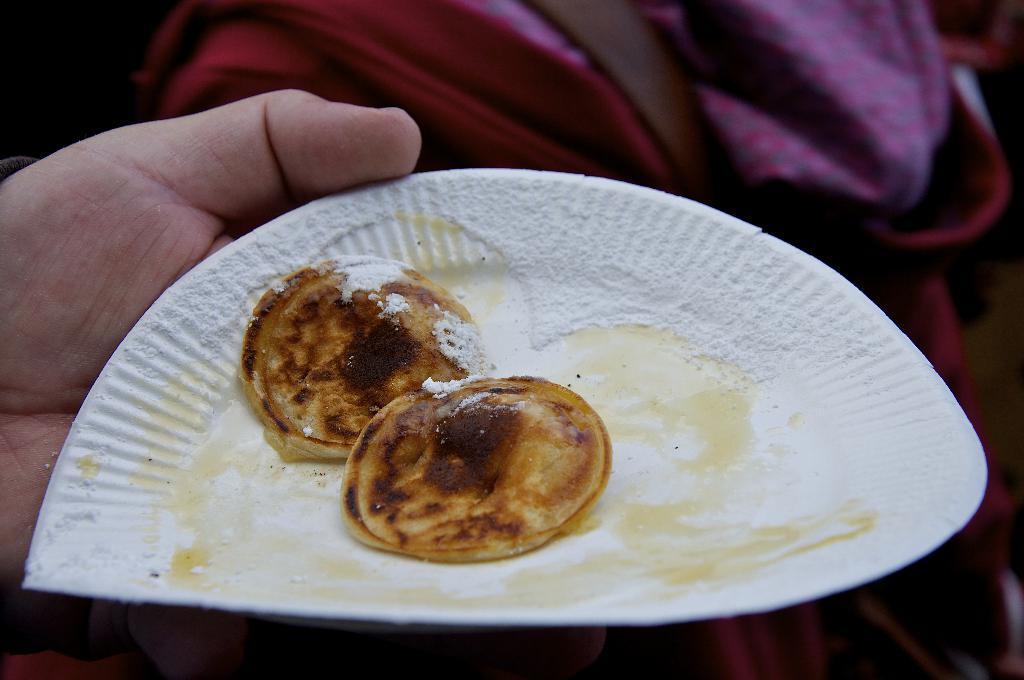In one or two sentences, can you explain what this image depicts? In this image we can see a person's hand holding a plate in which pickert is there. In the background the image is in a blur. 